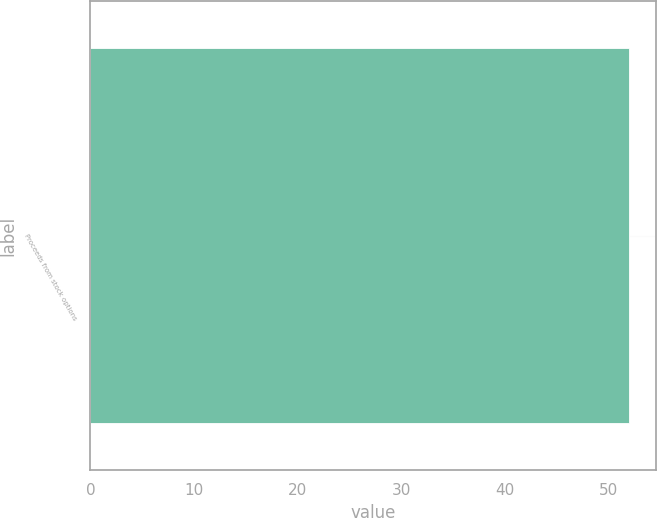<chart> <loc_0><loc_0><loc_500><loc_500><bar_chart><fcel>Proceeds from stock options<nl><fcel>52<nl></chart> 